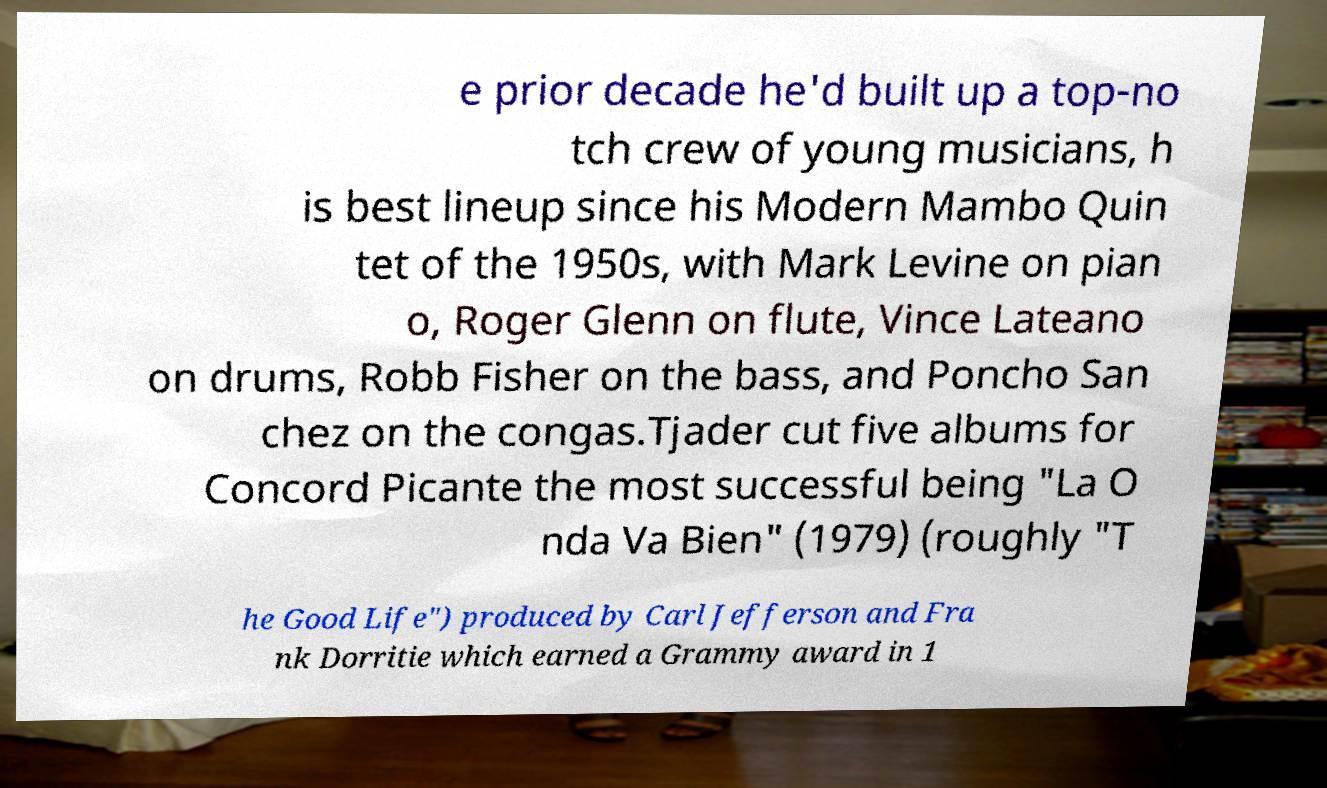I need the written content from this picture converted into text. Can you do that? e prior decade he'd built up a top-no tch crew of young musicians, h is best lineup since his Modern Mambo Quin tet of the 1950s, with Mark Levine on pian o, Roger Glenn on flute, Vince Lateano on drums, Robb Fisher on the bass, and Poncho San chez on the congas.Tjader cut five albums for Concord Picante the most successful being "La O nda Va Bien" (1979) (roughly "T he Good Life") produced by Carl Jefferson and Fra nk Dorritie which earned a Grammy award in 1 